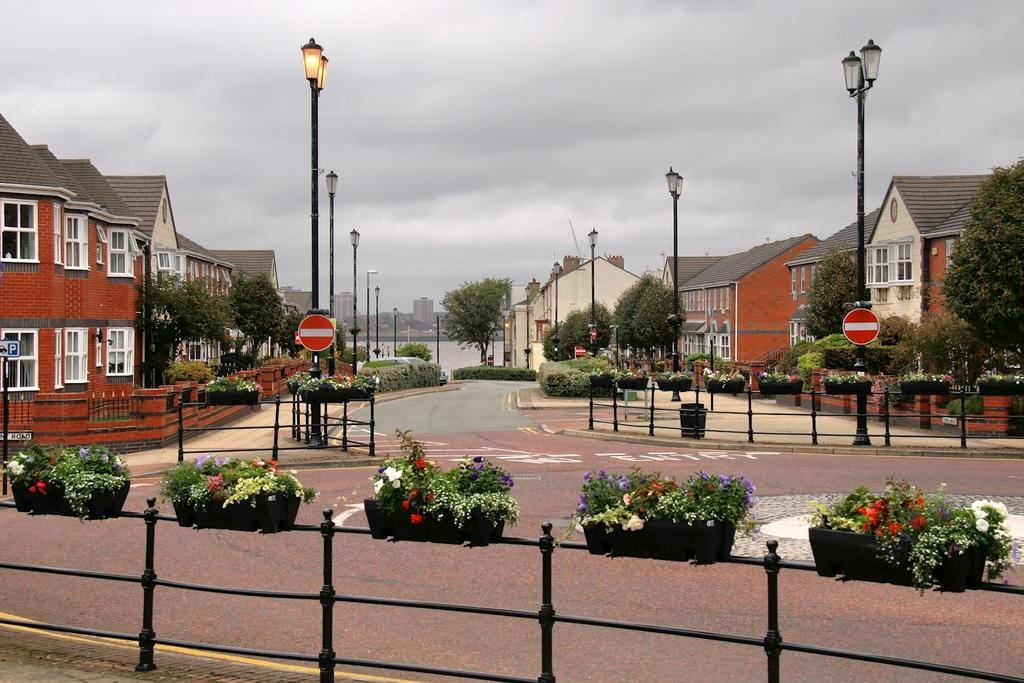What type of plants can be seen in the image? There are plants with flowers in the image. How are the plants arranged or contained? The plants are in pots. What other objects are present in the image? There are iron rods, poles, lights, houses, trees, a road, and boards in the image. What can be seen in the background of the image? The sky is visible in the background of the image. What type of quince is being used as a scene prop in the image? There is no quince present in the image. What impulse caused the plants to suddenly grow in the image? The plants' growth is not depicted as sudden or influenced by an impulse in the image. 